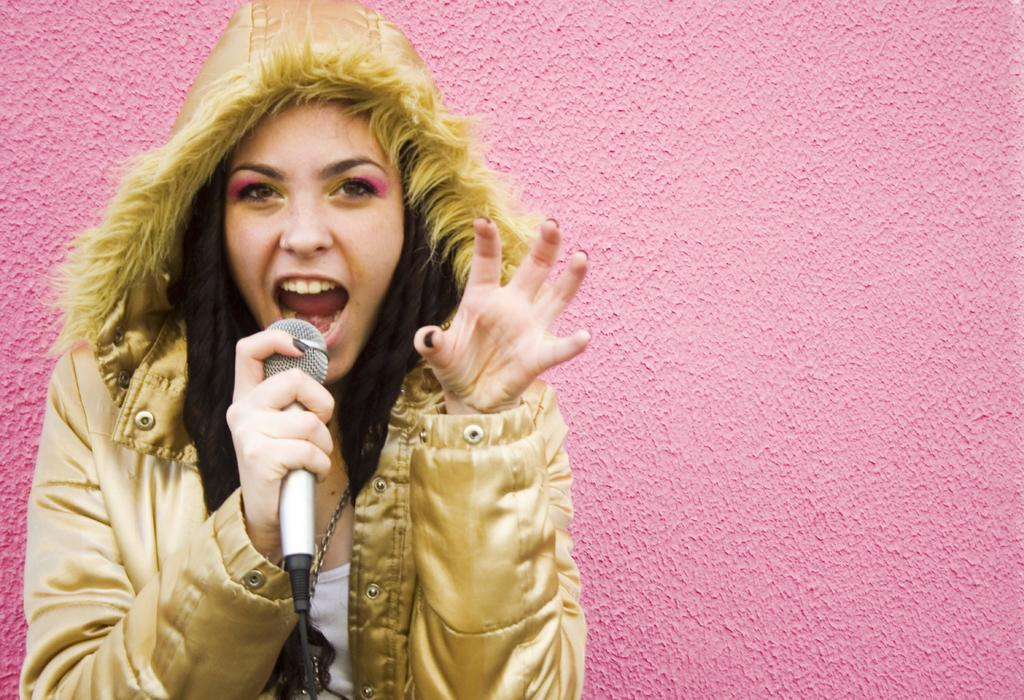Who is the main subject in the image? There is a woman in the image. What is the woman holding in the image? The woman is holding a microphone. Can you see any eggs in the image? There are no eggs present in the image. 